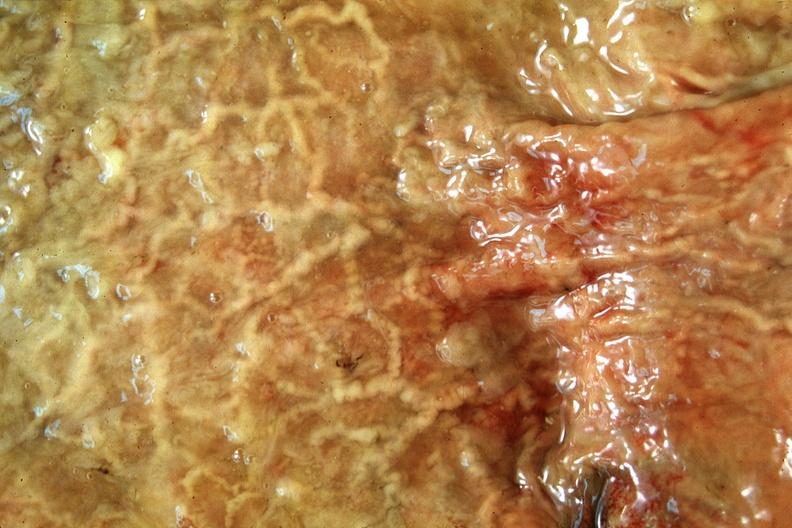what is present?
Answer the question using a single word or phrase. Gastrointestinal 